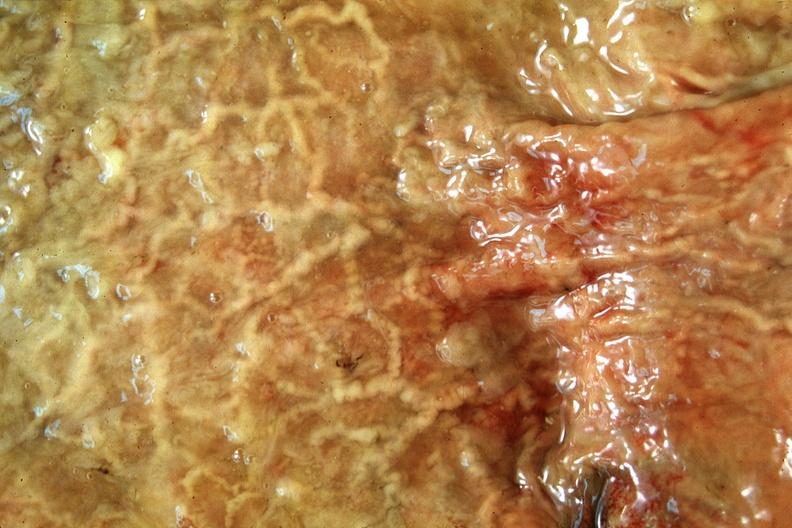what is present?
Answer the question using a single word or phrase. Gastrointestinal 